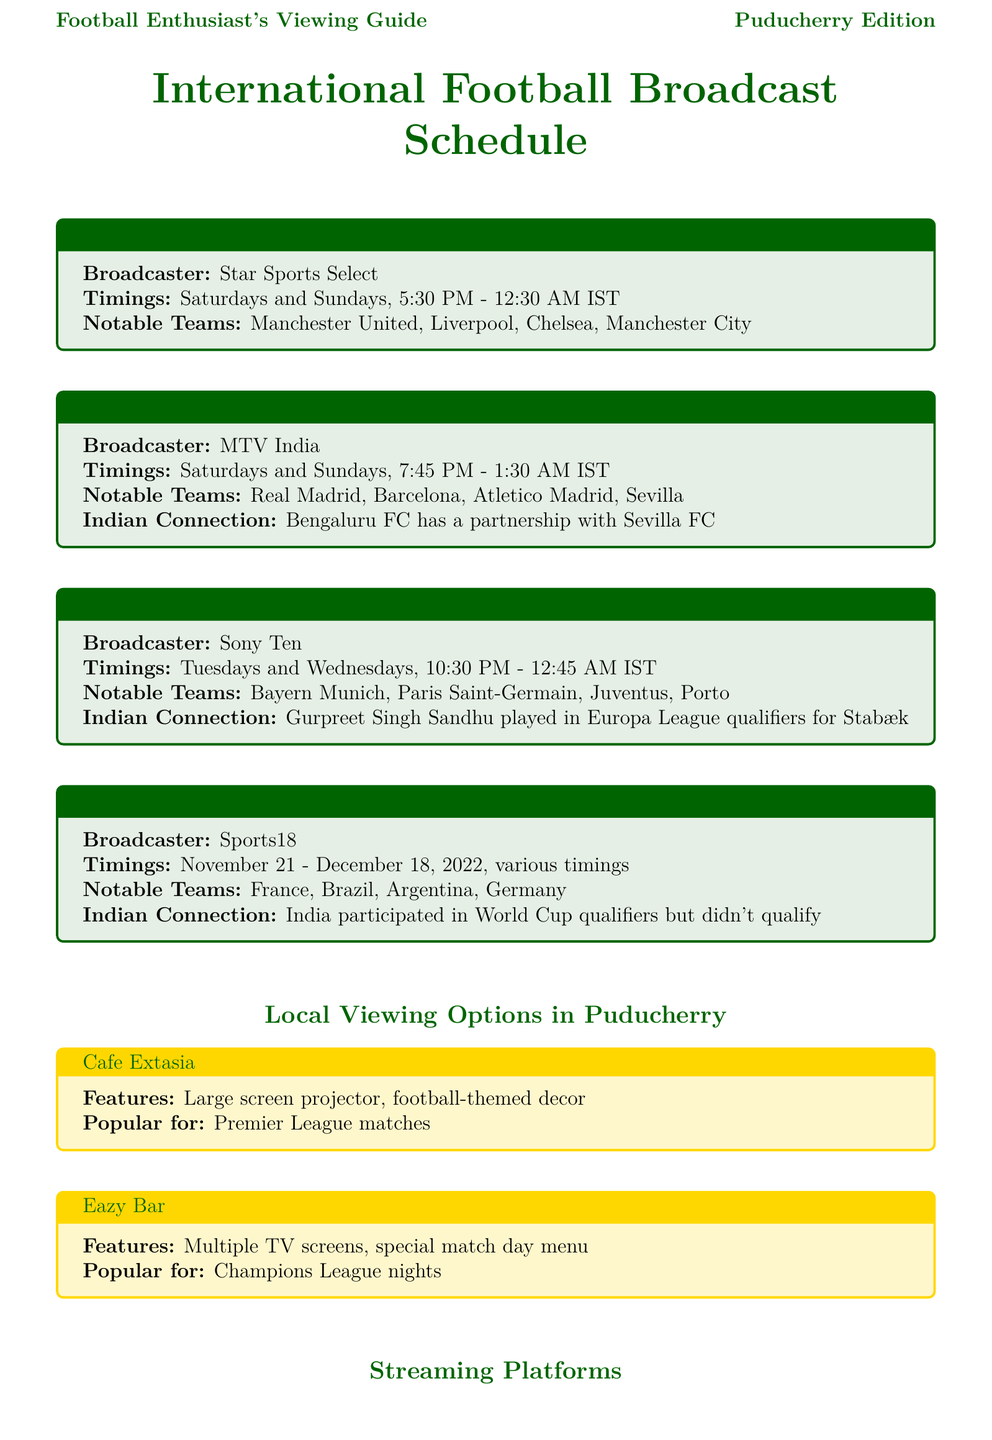What is the broadcaster for the English Premier League? The broadcaster for the English Premier League is Star Sports Select, as indicated in the league details.
Answer: Star Sports Select What are the timings for La Liga broadcasts? The timings for La Liga broadcasts are specified as Saturdays and Sundays, from 7:45 PM to 1:30 AM IST.
Answer: Saturdays and Sundays, 7:45 PM - 1:30 AM IST Which platform offers UEFA Champions League streaming? The platform that offers UEFA Champions League streaming is mentioned in the streaming section of the document.
Answer: SonyLIV What notable teams are featured in FIFA World Cup 2022? The notable teams for FIFA World Cup 2022 are listed in the corresponding section of the document.
Answer: France, Brazil, Argentina, Germany Which local viewing option is popular for Premier League matches? The local viewing option that is popular for Premier League matches is stated clearly within the local viewing options.
Answer: Cafe Extasia How much does a monthly subscription for Hotstar cost? The monthly subscription cost for Hotstar is stated in the streaming platforms section of the document.
Answer: ₹299 per month What is the venue for the Puducherry Football League? The venue for the Puducherry Football League is indicated under the local football events section.
Answer: Indira Gandhi Sports Complex, Puducherry Which teams participate in the Puducherry Football League? The document specifies the teams participating in the Puducherry Football League in the local events section.
Answer: Pondicherry City FC, Karaikal FC, Mahe United What is the Indian connection mentioned for UEFA Champions League? The Indian connection for the UEFA Champions League is described in the related section.
Answer: Gurpreet Singh Sandhu played in Europa League qualifiers for Stabæk 